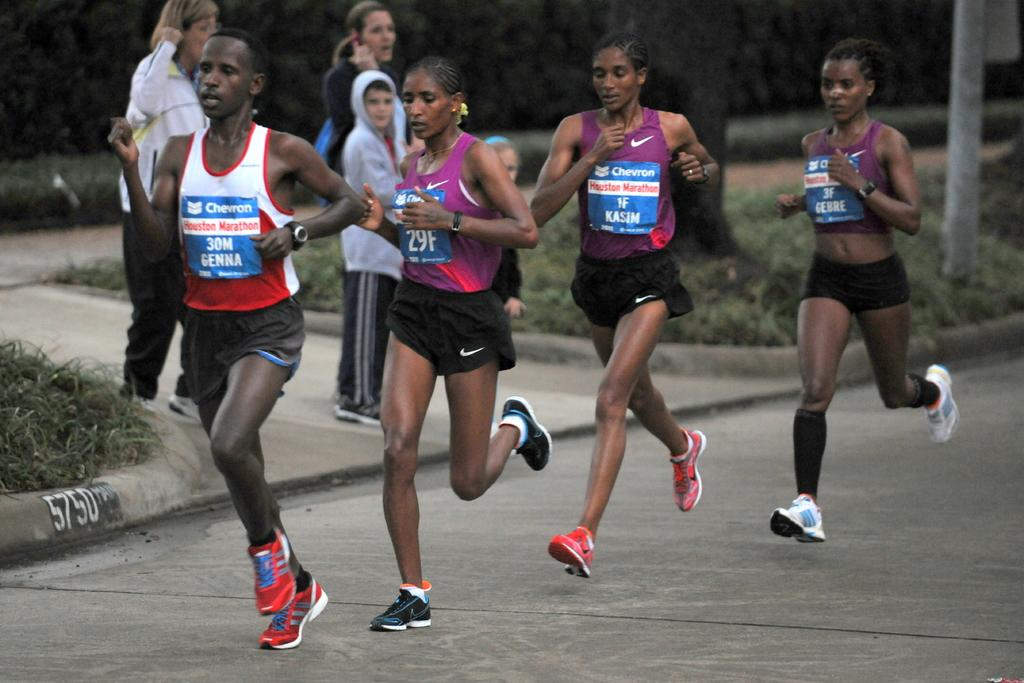What are the people in the image doing? There is a group of people running and a group of people standing in the image. What can be seen in the background of the image? There are trees in the image. What is the tall, vertical object in the image? There is a pole in the image. What is at the bottom of the image? There is a road at the bottom of the image. How many bits are visible in the image? There are no bits present in the image. Are there any chickens running alongside the people in the image? There are no chickens present in the image. 